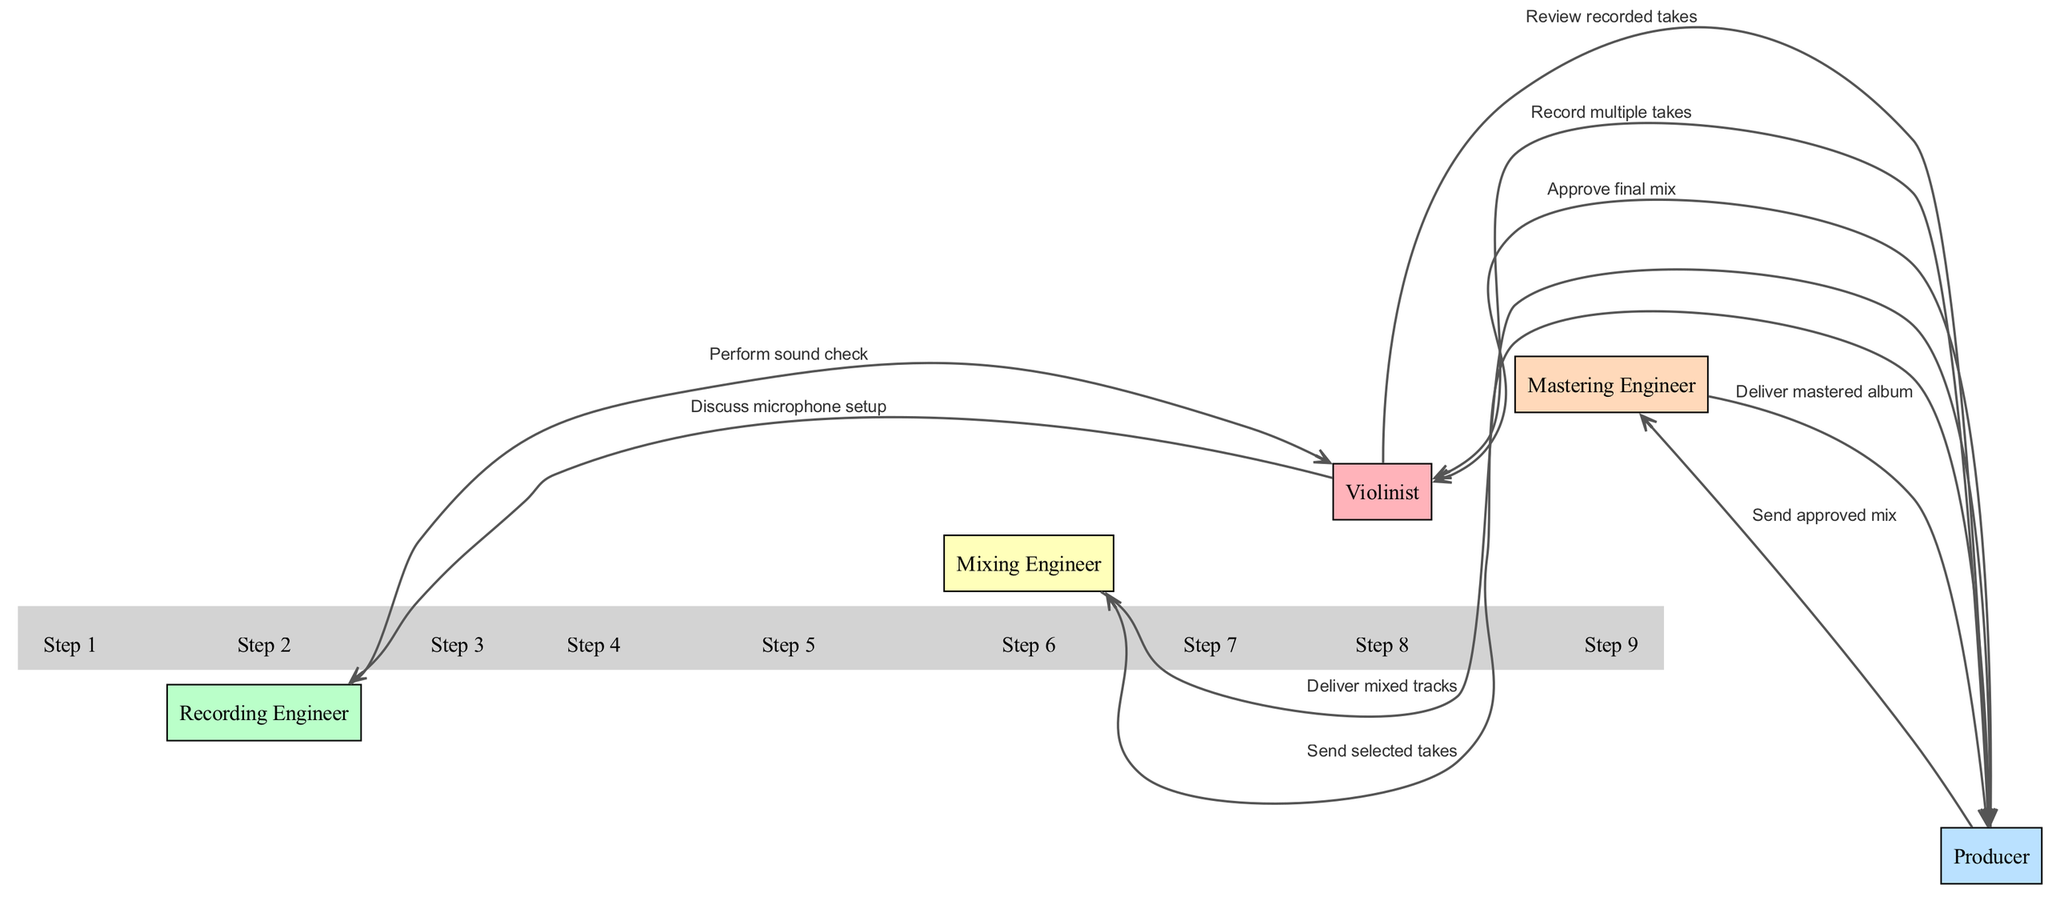What is the first step in the recording process? The first step in the recording process is the "Discuss microphone setup," which occurs between the Violinist and the Recording Engineer. It is the first message exchanged in the sequence.
Answer: Discuss microphone setup How many total actors are involved in the process? The diagram shows five actors: Violinist, Recording Engineer, Producer, Mixing Engineer, and Mastering Engineer. Counting each listed actor gives a total of five.
Answer: Five Who delivers the mixed tracks? The Mixing Engineer delivers the mixed tracks to the Producer, as indicated by the directed edge in the diagram showing this message exchange.
Answer: Mixing Engineer What is the last message exchanged in the diagram? The last message exchanged in the sequence is "Deliver mastered album" from the Mastering Engineer to the Producer. This is the final step in the processing flow.
Answer: Deliver mastered album What is the sequence of steps leading to the final mastering? The sequence of steps involves recording multiple takes, reviewing recorded takes, sending selected takes to the Mixing Engineer, delivering mixed tracks, and sending the approved mix to the Mastering Engineer for final delivery. Each of these steps builds on the previous to reach the final mastering.
Answer: Record multiple takes, Review recorded takes, Send selected takes, Deliver mixed tracks, Send approved mix Which actor is involved in approving the final mix? The Producer is responsible for approving the final mix, as shown by the message "Approve final mix" that goes from the Producer to the Violinist.
Answer: Producer Which actor initiates the recording takes? The initiator for the recording takes is the Producer, who is responsible for instructing the Violinist with the message "Record multiple takes." This indicates the Producer's role in starting the recording process.
Answer: Producer How many messages are exchanged in total? There are eight messages exchanged in the sequence diagram, as each step of interaction between the actors is represented by a message.
Answer: Eight 